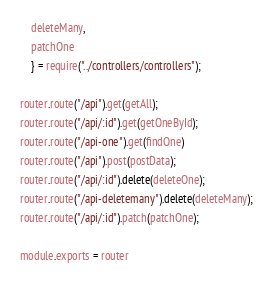Convert code to text. <code><loc_0><loc_0><loc_500><loc_500><_JavaScript_>    deleteMany,
    patchOne
    } = require("../controllers/controllers");

router.route("/api").get(getAll);
router.route("/api/:id").get(getOneById);
router.route("/api-one").get(findOne)
router.route("/api").post(postData);
router.route("/api/:id").delete(deleteOne);
router.route("/api-deletemany").delete(deleteMany);
router.route("/api/:id").patch(patchOne);

module.exports = router</code> 